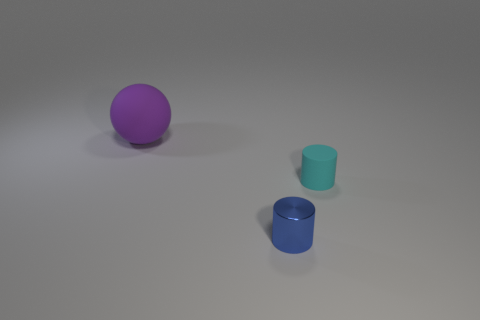Is there any other thing that has the same size as the sphere?
Keep it short and to the point. No. Is there any other thing that has the same material as the blue thing?
Your answer should be very brief. No. Is the purple ball made of the same material as the small object to the left of the small cyan object?
Provide a short and direct response. No. Are there more matte balls to the left of the cyan matte thing than large brown rubber blocks?
Provide a short and direct response. Yes. Are there any big yellow spheres that have the same material as the small blue cylinder?
Give a very brief answer. No. Do the tiny thing that is behind the tiny shiny cylinder and the object behind the tiny cyan cylinder have the same material?
Offer a very short reply. Yes. Is the number of purple matte things behind the purple object the same as the number of small objects left of the small cyan object?
Offer a very short reply. No. The metallic object that is the same size as the cyan rubber thing is what color?
Give a very brief answer. Blue. How many things are either cylinders on the right side of the metal object or tiny blue shiny things?
Provide a short and direct response. 2. How many other objects are there of the same size as the shiny cylinder?
Keep it short and to the point. 1. 